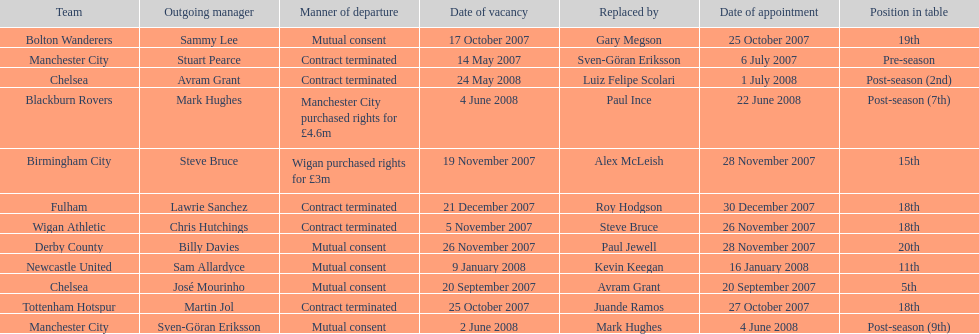What was the only team to place 5th called? Chelsea. 